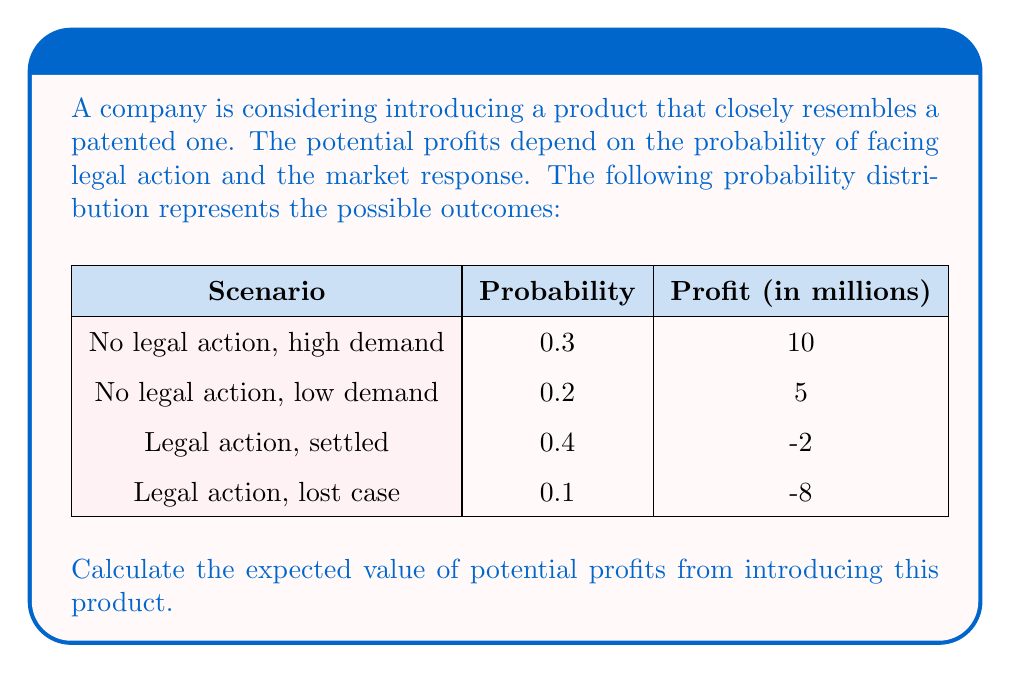Solve this math problem. To calculate the expected value of potential profits, we need to multiply each possible profit outcome by its probability and then sum these products. Let's follow these steps:

1) For "No legal action, high demand":
   $E_1 = 0.3 \times 10 = 3$ million

2) For "No legal action, low demand":
   $E_2 = 0.2 \times 5 = 1$ million

3) For "Legal action, settled":
   $E_3 = 0.4 \times (-2) = -0.8$ million

4) For "Legal action, lost case":
   $E_4 = 0.1 \times (-8) = -0.8$ million

5) Sum all these expected values:
   $E(\text{Profit}) = E_1 + E_2 + E_3 + E_4$
   $E(\text{Profit}) = 3 + 1 + (-0.8) + (-0.8) = 2.4$ million

Therefore, the expected value of potential profits is $2.4 million.
Answer: $2.4 million 